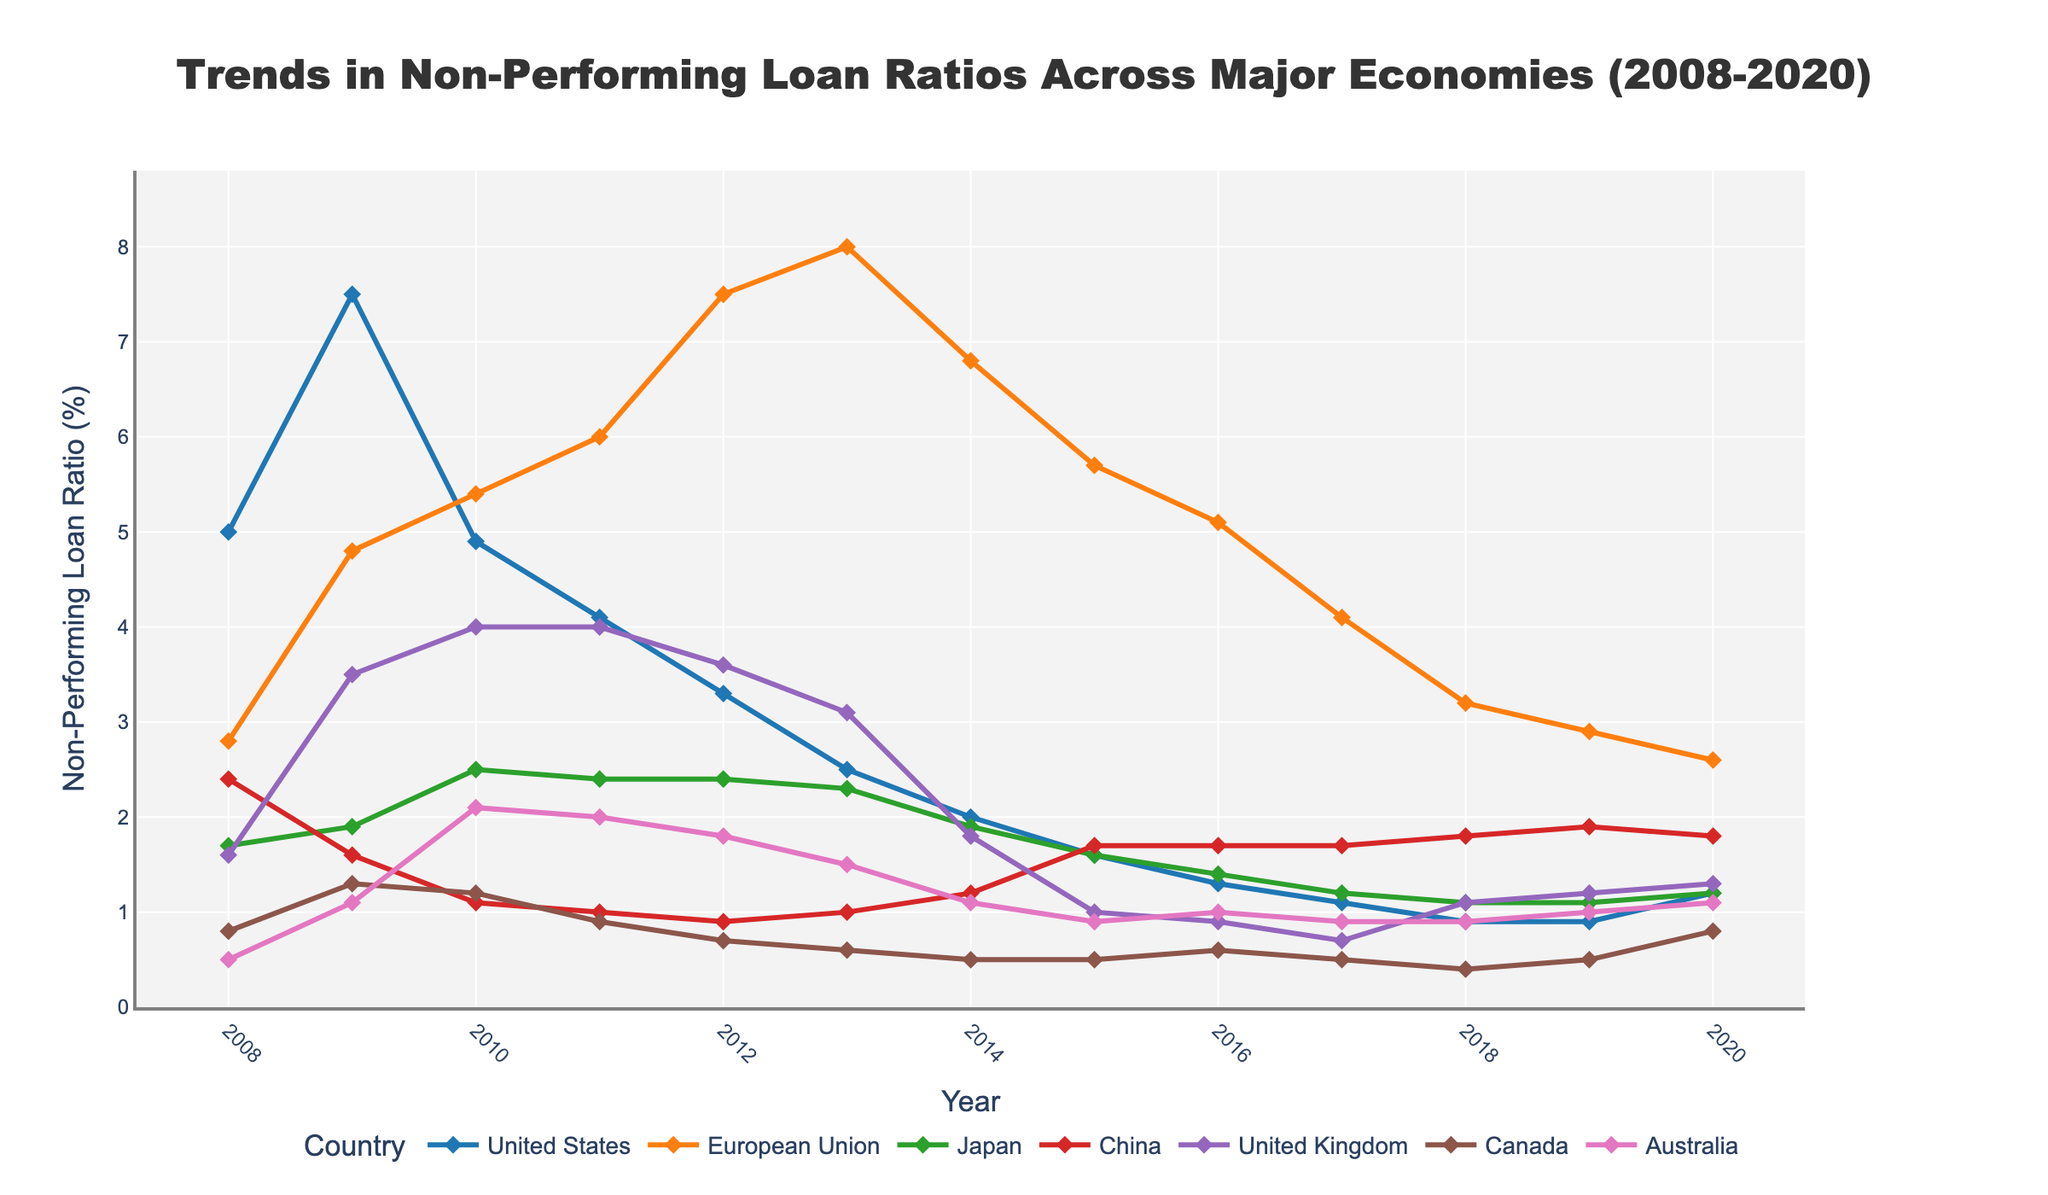Which country experienced the highest non-performing loan (NPL) ratio in 2009? By examining the plot, the highest peak in 2009 is associated with the United States, reaching a significant value far higher than other countries.
Answer: United States What's the trend in the non-performing loan ratio for China from 2008 to 2020? Observing the line corresponding to China, it starts around 2.4% in 2008, decreases to 1.0% by 2011, remains relatively stable around 1.7-1.8% between 2015 and 2020, showing slight fluctuations but overall relatively stable compared to other countries.
Answer: Stable with slight fluctuations Between 2008 and 2020, which country displayed the most significant improvement (drop) in their non-performing loan ratio? To determine this, note the starting and ending values for each country. The United States shows the most significant drop from 5.0% in 2008 to about 1.2% in 2020, indicating consistent improvement.
Answer: United States During which year did the European Union reach its peak non-performing loan ratio, and what was the value? By observing the European Union's line, the peak occurs around 2013, where the ratio is highest at approximately 8.0%.
Answer: 2013 at approximately 8.0% Compare the non-performing loan ratios of Japan and Australia in 2015. Which country had a lower ratio? Referring to the plot data for 2015, Japan's NPL ratio was around 1.6%, whereas Australia's was approximately 0.9%. Thus, Australia had a lower NPL ratio in 2015.
Answer: Australia What was the combined non-performing loan ratio for the United States and the United Kingdom in 2010? The ratio for the United States in 2010 is about 4.9% and for the United Kingdom, it is approximately 4.0%. The combined figure is 4.9 + 4.0 = 8.9%.
Answer: 8.9% Identify the years in which Canada’s non-performing loan ratio was at its lowest and its highest from 2008 to 2020. The plot shows Canada’s lowest ratio in 2018 at 0.4%, and the highest ratio is in 2009 at 1.3%.
Answer: 2018 (lowest), 2009 (highest) Which country among all listed showed the least variation in its non-performing loan ratio from 2008 to 2020? By examining the plot, Japan shows a relatively flat and stable line from 2008 to 2020, varying only slightly around 1.1% to 2.5%.
Answer: Japan What is the difference in non-performing loan ratios between the United Kingdom and the European Union in 2014? From the data, the UK's NPL ratio is about 1.8% while the European Union's is approximately 6.8%. The difference is 6.8 - 1.8 = 5.0%.
Answer: 5.0% In which year did Australia’s non-performing loan ratio intersect with China’s, and what was the approximate ratio at that time? The plot shows the lines of Australia and China intersecting around 2015 at an approximate value of 1.7%.
Answer: 2015 at approximately 1.7% 